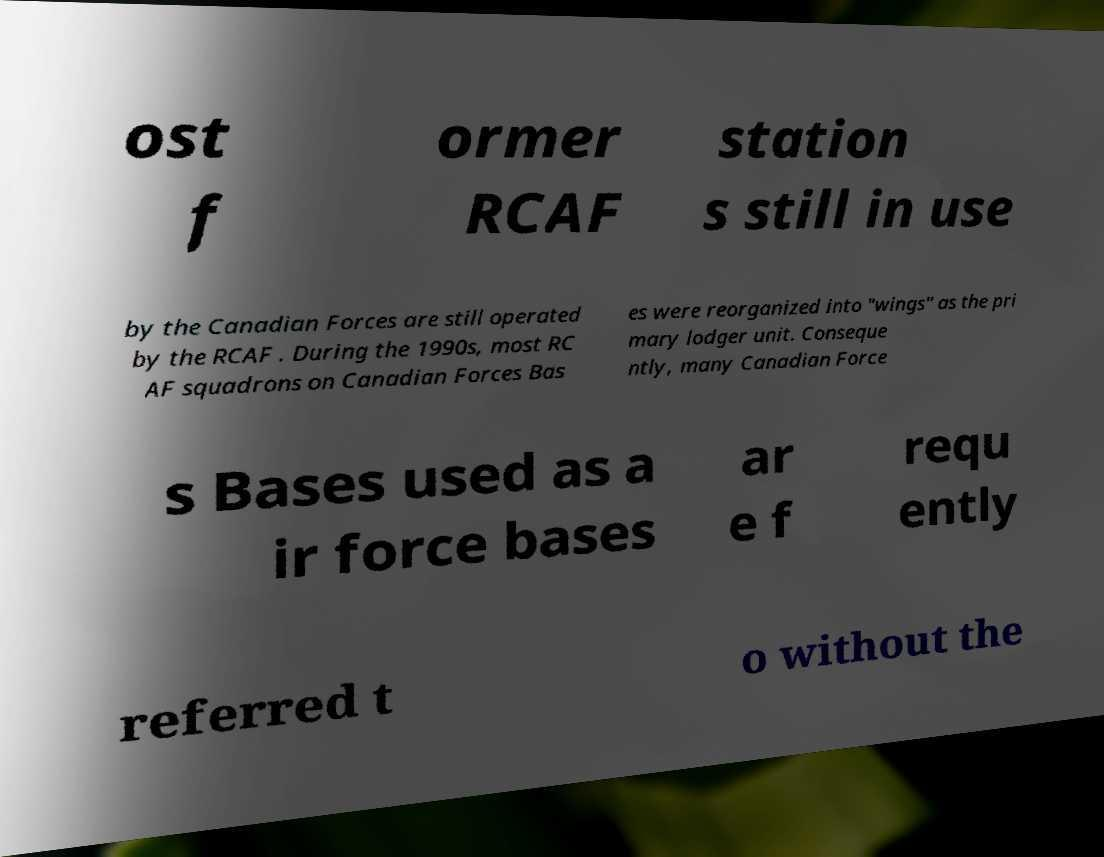Please read and relay the text visible in this image. What does it say? ost f ormer RCAF station s still in use by the Canadian Forces are still operated by the RCAF . During the 1990s, most RC AF squadrons on Canadian Forces Bas es were reorganized into "wings" as the pri mary lodger unit. Conseque ntly, many Canadian Force s Bases used as a ir force bases ar e f requ ently referred t o without the 